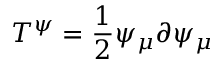Convert formula to latex. <formula><loc_0><loc_0><loc_500><loc_500>T ^ { \psi } = \frac { 1 } { 2 } \psi _ { \mu } \partial \psi _ { \mu }</formula> 